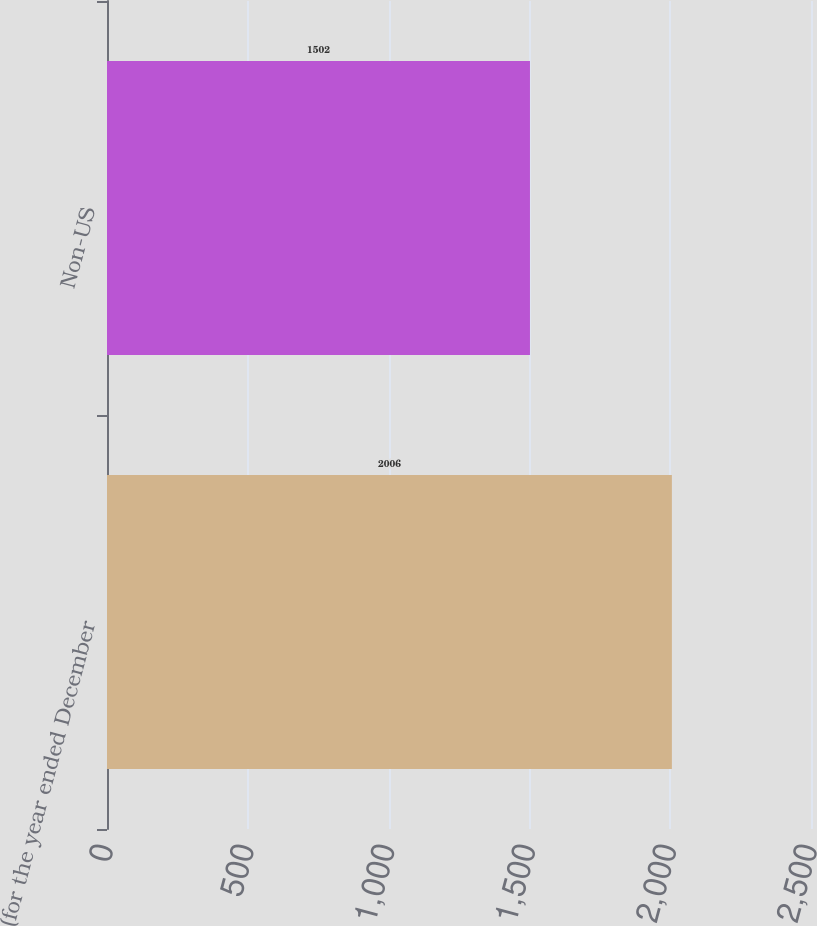<chart> <loc_0><loc_0><loc_500><loc_500><bar_chart><fcel>(for the year ended December<fcel>Non-US<nl><fcel>2006<fcel>1502<nl></chart> 